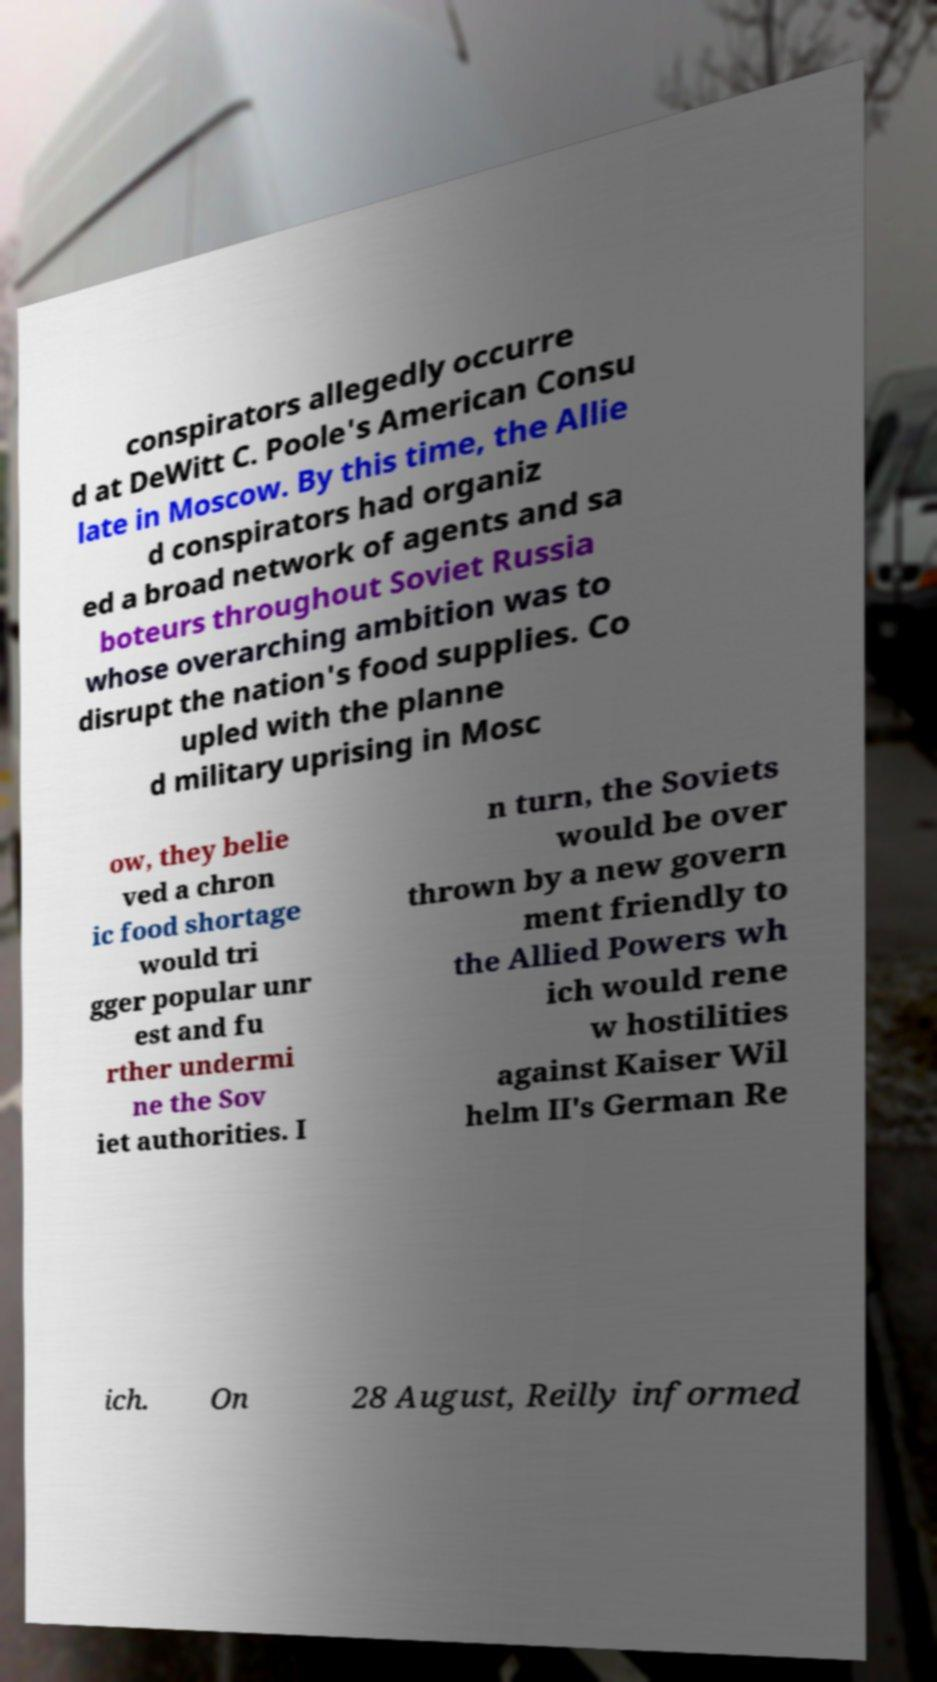Please read and relay the text visible in this image. What does it say? conspirators allegedly occurre d at DeWitt C. Poole's American Consu late in Moscow. By this time, the Allie d conspirators had organiz ed a broad network of agents and sa boteurs throughout Soviet Russia whose overarching ambition was to disrupt the nation's food supplies. Co upled with the planne d military uprising in Mosc ow, they belie ved a chron ic food shortage would tri gger popular unr est and fu rther undermi ne the Sov iet authorities. I n turn, the Soviets would be over thrown by a new govern ment friendly to the Allied Powers wh ich would rene w hostilities against Kaiser Wil helm II's German Re ich. On 28 August, Reilly informed 